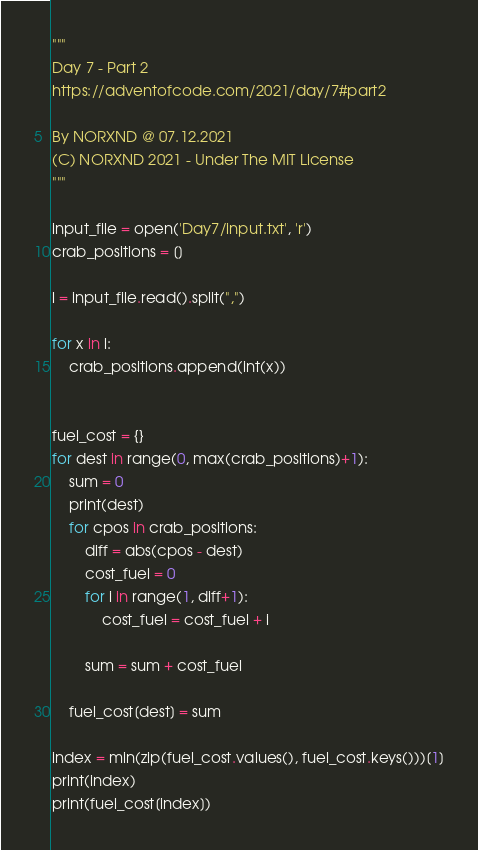Convert code to text. <code><loc_0><loc_0><loc_500><loc_500><_Python_>"""
Day 7 - Part 2
https://adventofcode.com/2021/day/7#part2

By NORXND @ 07.12.2021
(C) NORXND 2021 - Under The MIT License
"""

input_file = open('Day7/input.txt', 'r')
crab_positions = []

l = input_file.read().split(",")

for x in l:
    crab_positions.append(int(x))


fuel_cost = {}
for dest in range(0, max(crab_positions)+1):
    sum = 0
    print(dest)
    for cpos in crab_positions:
        diff = abs(cpos - dest)
        cost_fuel = 0
        for i in range(1, diff+1):
            cost_fuel = cost_fuel + i

        sum = sum + cost_fuel
    
    fuel_cost[dest] = sum

index = min(zip(fuel_cost.values(), fuel_cost.keys()))[1]
print(index)
print(fuel_cost[index])</code> 